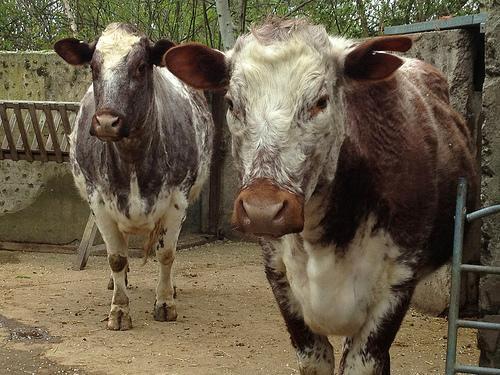How many cows are in the picture?
Give a very brief answer. 2. 